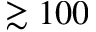<formula> <loc_0><loc_0><loc_500><loc_500>\gtrsim 1 0 0</formula> 